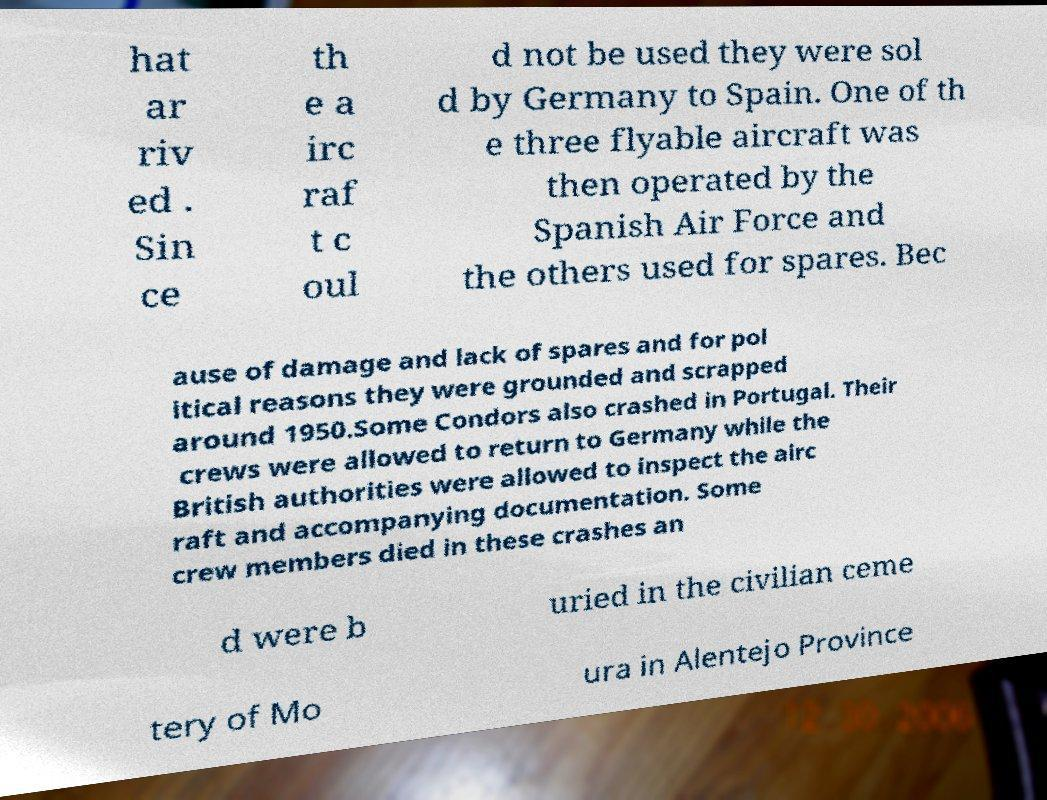What messages or text are displayed in this image? I need them in a readable, typed format. hat ar riv ed . Sin ce th e a irc raf t c oul d not be used they were sol d by Germany to Spain. One of th e three flyable aircraft was then operated by the Spanish Air Force and the others used for spares. Bec ause of damage and lack of spares and for pol itical reasons they were grounded and scrapped around 1950.Some Condors also crashed in Portugal. Their crews were allowed to return to Germany while the British authorities were allowed to inspect the airc raft and accompanying documentation. Some crew members died in these crashes an d were b uried in the civilian ceme tery of Mo ura in Alentejo Province 